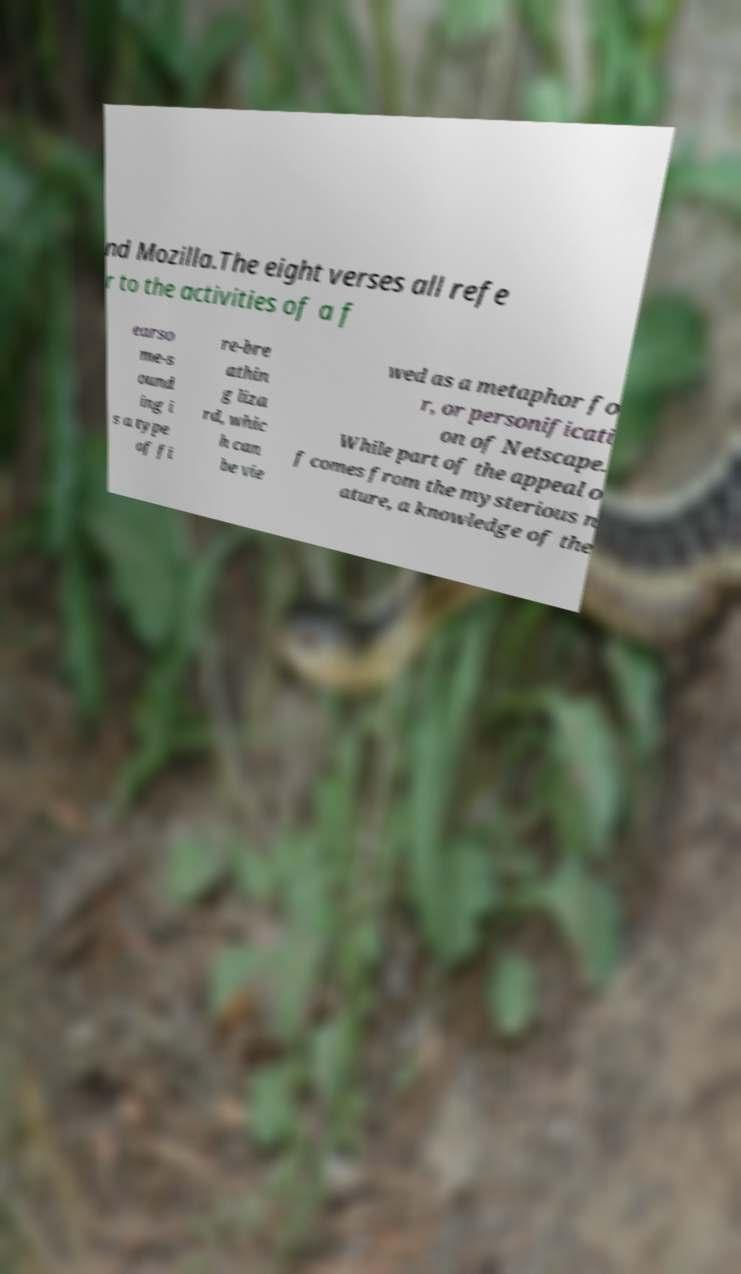There's text embedded in this image that I need extracted. Can you transcribe it verbatim? nd Mozilla.The eight verses all refe r to the activities of a f earso me-s ound ing i s a type of fi re-bre athin g liza rd, whic h can be vie wed as a metaphor fo r, or personificati on of Netscape. While part of the appeal o f comes from the mysterious n ature, a knowledge of the 